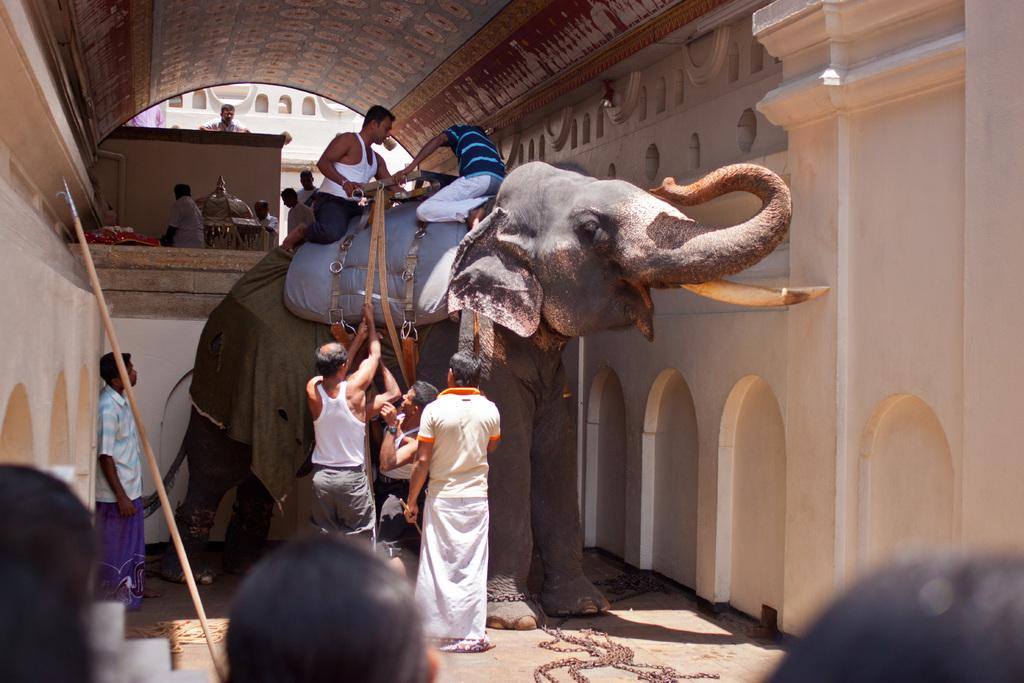What animal is present in the image? There is an elephant in the image. Are there any people interacting with the elephant? Yes, there are two people sitting on the elephant. Are there any other people near the elephant? Yes, there are multiple people near the elephant. What might these people be doing? These people appear to be working. Can you see any wounds on the elephant in the image? There is no mention of any wounds on the elephant in the provided facts, so we cannot determine if any are present. 